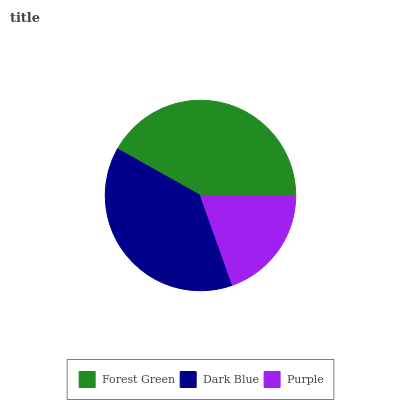Is Purple the minimum?
Answer yes or no. Yes. Is Forest Green the maximum?
Answer yes or no. Yes. Is Dark Blue the minimum?
Answer yes or no. No. Is Dark Blue the maximum?
Answer yes or no. No. Is Forest Green greater than Dark Blue?
Answer yes or no. Yes. Is Dark Blue less than Forest Green?
Answer yes or no. Yes. Is Dark Blue greater than Forest Green?
Answer yes or no. No. Is Forest Green less than Dark Blue?
Answer yes or no. No. Is Dark Blue the high median?
Answer yes or no. Yes. Is Dark Blue the low median?
Answer yes or no. Yes. Is Purple the high median?
Answer yes or no. No. Is Purple the low median?
Answer yes or no. No. 